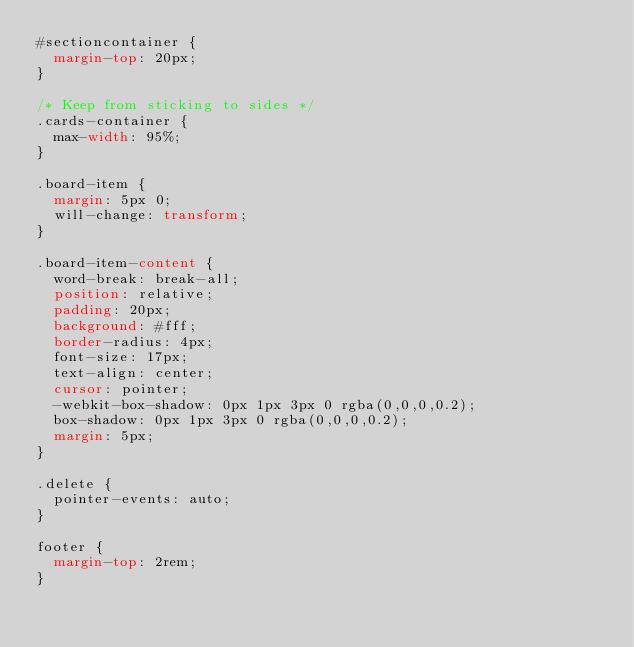<code> <loc_0><loc_0><loc_500><loc_500><_CSS_>#sectioncontainer {
  margin-top: 20px;
}

/* Keep from sticking to sides */
.cards-container {
  max-width: 95%;
}

.board-item {
  margin: 5px 0;
  will-change: transform;
}

.board-item-content {
  word-break: break-all;
  position: relative;
  padding: 20px;
  background: #fff;
  border-radius: 4px;
  font-size: 17px;
  text-align: center;
  cursor: pointer;
  -webkit-box-shadow: 0px 1px 3px 0 rgba(0,0,0,0.2);
  box-shadow: 0px 1px 3px 0 rgba(0,0,0,0.2);
  margin: 5px;
}

.delete {
  pointer-events: auto;
}

footer {
  margin-top: 2rem;
}</code> 